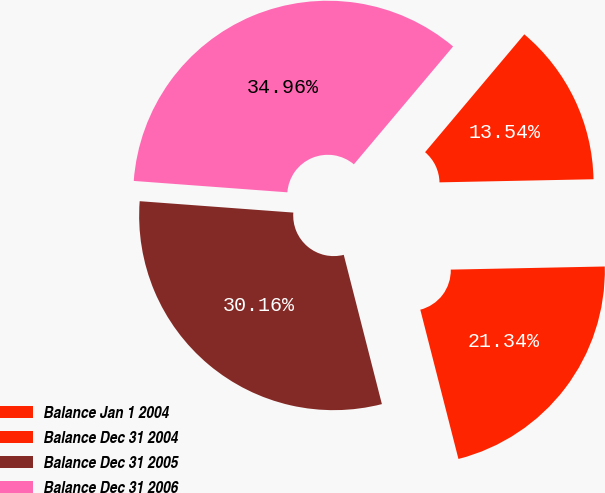Convert chart to OTSL. <chart><loc_0><loc_0><loc_500><loc_500><pie_chart><fcel>Balance Jan 1 2004<fcel>Balance Dec 31 2004<fcel>Balance Dec 31 2005<fcel>Balance Dec 31 2006<nl><fcel>13.54%<fcel>21.34%<fcel>30.16%<fcel>34.96%<nl></chart> 